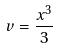<formula> <loc_0><loc_0><loc_500><loc_500>v = \frac { x ^ { 3 } } { 3 }</formula> 